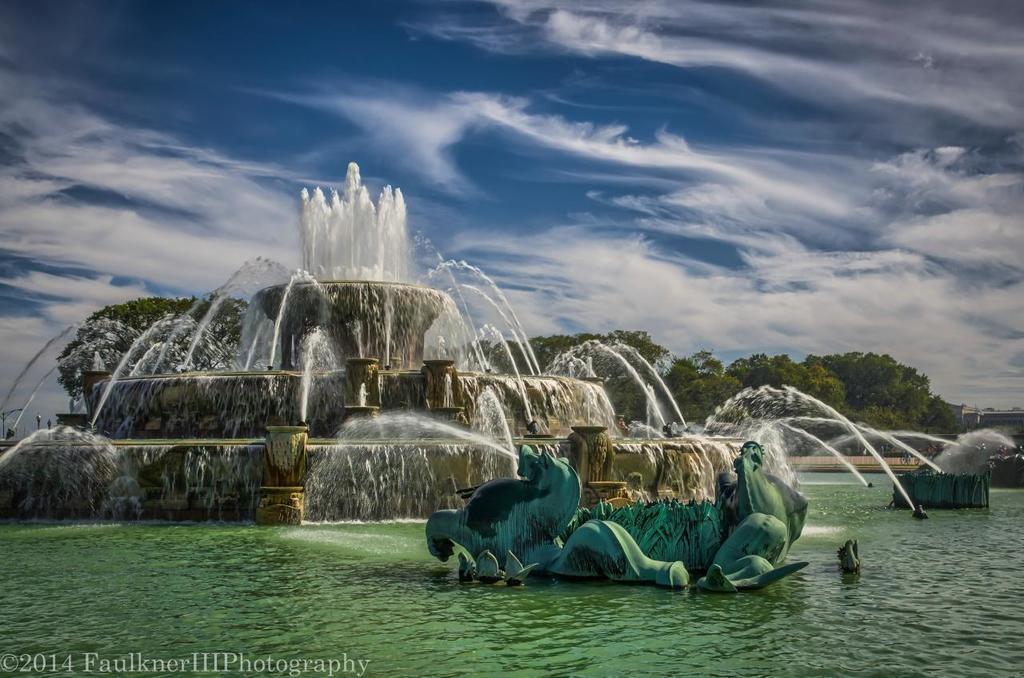Could you give a brief overview of what you see in this image? This is an animated image. In this image, on the right side, we can see a sculpture which is placed on the water. On the right side, we can see some fountains, buildings. In the background, we can see some fountains, trees. At the top, we can see a sky which is cloudy, at the bottom, we can see a water in a lake. 